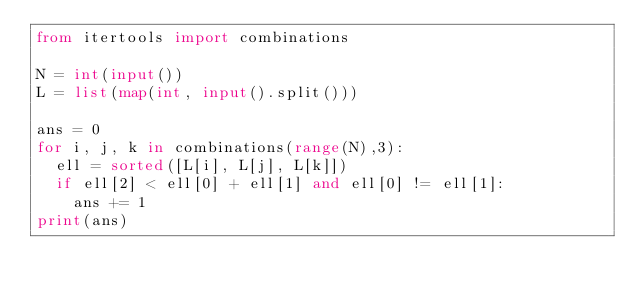Convert code to text. <code><loc_0><loc_0><loc_500><loc_500><_Python_>from itertools import combinations

N = int(input())
L = list(map(int, input().split()))

ans = 0
for i, j, k in combinations(range(N),3):
  ell = sorted([L[i], L[j], L[k]])
  if ell[2] < ell[0] + ell[1] and ell[0] != ell[1]:
    ans += 1
print(ans)</code> 